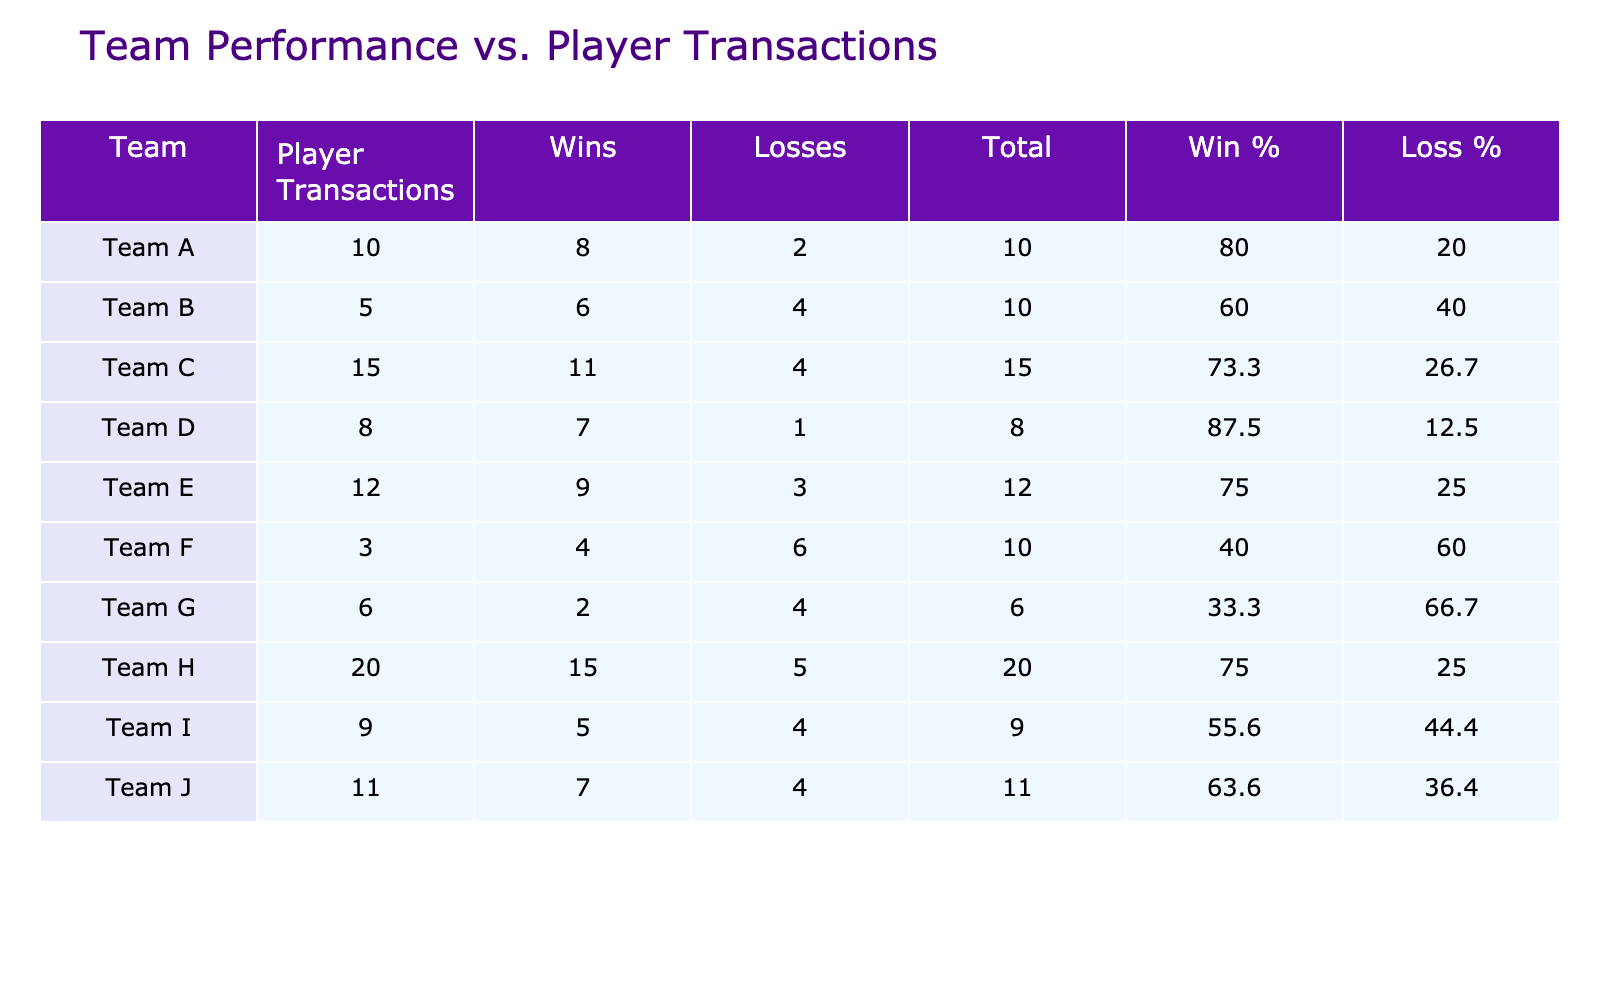What team had the highest number of player transactions? Team H had 20 player transactions, which is the highest compared to other teams listed in the table.
Answer: Team H What is the win percentage for Team C? Team C has 11 wins and 4 losses, which totals 15 games played (11 + 4). The win percentage is calculated as (11 / 15) * 100 = 73.3%.
Answer: 73.3% Which team has the fewest losses, and what is that number? Team D has the fewest losses with just 1 loss, as shown in the losses column of the table.
Answer: 1 Is it true that Team A has more wins than Team I? Team A has 8 wins, while Team I has 5 wins. Since 8 is greater than 5, it is true that Team A has more wins than Team I.
Answer: Yes What is the average number of player transactions for teams with at least 10 wins? Teams with at least 10 wins are Team C (15), Team H (20), and Team E (12). Adding these gives 15 + 20 + 12 = 47. There are 3 teams, so the average is 47 / 3 = 15.67.
Answer: 15.67 How many teams have a win percentage greater than 60%? To find this, we calculate the win percentages for each team: Team A (80%), Team B (60%), Team C (73.3%), Team D (87.5%), Team E (75%), Team F (40%), Team G (33.3%), Team H (75%), Team I (55.6%), and Team J (63.6%). The teams with win percentages greater than 60% are Team A, Team C, Team D, Team E, Team H, and Team J. Therefore, there are 6 teams.
Answer: 6 Which team has a win-loss ratio of 2:1? The win-loss ratio of a team is calculated by dividing the number of wins by the number of losses. Team A has 8 wins and 2 losses, giving a win-loss ratio of 8/2 = 4, Team B has 6/4 = 1.5, Team C has 11/4 = 2.75, Team D has 7/1 = 7, Team E has 9/3 = 3, Team F has 4/6 = 0.67, Team G has 2/4 = 0.5, Team H has 15/5 = 3, Team I has 5/4 = 1.25, and Team J has 7/4 = 1.75. None match the ratio exactly 2:1.
Answer: None 